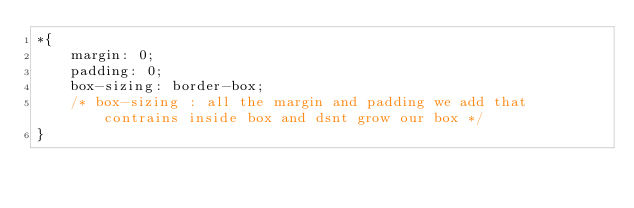<code> <loc_0><loc_0><loc_500><loc_500><_CSS_>*{
    margin: 0;
    padding: 0;
    box-sizing: border-box; 
    /* box-sizing : all the margin and padding we add that contrains inside box and dsnt grow our box */
}

</code> 